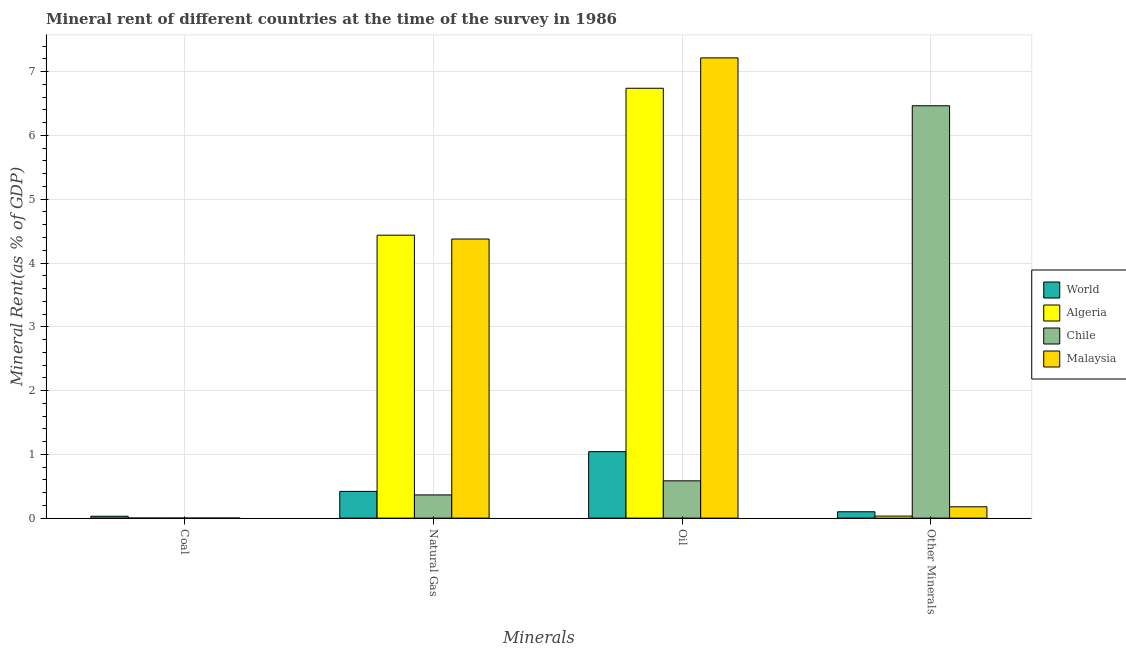How many different coloured bars are there?
Your response must be concise. 4. How many groups of bars are there?
Give a very brief answer. 4. Are the number of bars on each tick of the X-axis equal?
Ensure brevity in your answer.  Yes. What is the label of the 3rd group of bars from the left?
Keep it short and to the point. Oil. What is the natural gas rent in Chile?
Your response must be concise. 0.36. Across all countries, what is the maximum oil rent?
Offer a very short reply. 7.22. Across all countries, what is the minimum oil rent?
Offer a terse response. 0.58. In which country was the  rent of other minerals maximum?
Offer a very short reply. Chile. In which country was the  rent of other minerals minimum?
Ensure brevity in your answer.  Algeria. What is the total natural gas rent in the graph?
Keep it short and to the point. 9.6. What is the difference between the coal rent in Chile and that in Malaysia?
Your answer should be very brief. -0. What is the difference between the coal rent in World and the  rent of other minerals in Malaysia?
Your answer should be compact. -0.15. What is the average natural gas rent per country?
Ensure brevity in your answer.  2.4. What is the difference between the  rent of other minerals and coal rent in Malaysia?
Offer a terse response. 0.18. What is the ratio of the natural gas rent in Algeria to that in Malaysia?
Make the answer very short. 1.01. What is the difference between the highest and the second highest oil rent?
Keep it short and to the point. 0.48. What is the difference between the highest and the lowest coal rent?
Provide a succinct answer. 0.03. In how many countries, is the coal rent greater than the average coal rent taken over all countries?
Offer a very short reply. 1. Is the sum of the coal rent in Algeria and World greater than the maximum oil rent across all countries?
Keep it short and to the point. No. Is it the case that in every country, the sum of the coal rent and natural gas rent is greater than the oil rent?
Keep it short and to the point. No. Are all the bars in the graph horizontal?
Your answer should be compact. No. What is the difference between two consecutive major ticks on the Y-axis?
Offer a very short reply. 1. Are the values on the major ticks of Y-axis written in scientific E-notation?
Keep it short and to the point. No. Does the graph contain any zero values?
Your answer should be compact. No. What is the title of the graph?
Your answer should be compact. Mineral rent of different countries at the time of the survey in 1986. Does "Lebanon" appear as one of the legend labels in the graph?
Make the answer very short. No. What is the label or title of the X-axis?
Your answer should be very brief. Minerals. What is the label or title of the Y-axis?
Offer a very short reply. Mineral Rent(as % of GDP). What is the Mineral Rent(as % of GDP) in World in Coal?
Give a very brief answer. 0.03. What is the Mineral Rent(as % of GDP) of Algeria in Coal?
Make the answer very short. 1.11843058632871e-6. What is the Mineral Rent(as % of GDP) of Chile in Coal?
Your answer should be compact. 0. What is the Mineral Rent(as % of GDP) in Malaysia in Coal?
Your response must be concise. 0. What is the Mineral Rent(as % of GDP) in World in Natural Gas?
Offer a terse response. 0.42. What is the Mineral Rent(as % of GDP) of Algeria in Natural Gas?
Your answer should be compact. 4.44. What is the Mineral Rent(as % of GDP) in Chile in Natural Gas?
Offer a terse response. 0.36. What is the Mineral Rent(as % of GDP) of Malaysia in Natural Gas?
Provide a succinct answer. 4.38. What is the Mineral Rent(as % of GDP) of World in Oil?
Offer a terse response. 1.04. What is the Mineral Rent(as % of GDP) in Algeria in Oil?
Make the answer very short. 6.74. What is the Mineral Rent(as % of GDP) of Chile in Oil?
Your answer should be compact. 0.58. What is the Mineral Rent(as % of GDP) of Malaysia in Oil?
Ensure brevity in your answer.  7.22. What is the Mineral Rent(as % of GDP) in World in Other Minerals?
Keep it short and to the point. 0.1. What is the Mineral Rent(as % of GDP) of Algeria in Other Minerals?
Make the answer very short. 0.03. What is the Mineral Rent(as % of GDP) of Chile in Other Minerals?
Provide a succinct answer. 6.47. What is the Mineral Rent(as % of GDP) of Malaysia in Other Minerals?
Provide a short and direct response. 0.18. Across all Minerals, what is the maximum Mineral Rent(as % of GDP) of World?
Provide a succinct answer. 1.04. Across all Minerals, what is the maximum Mineral Rent(as % of GDP) in Algeria?
Provide a succinct answer. 6.74. Across all Minerals, what is the maximum Mineral Rent(as % of GDP) of Chile?
Give a very brief answer. 6.47. Across all Minerals, what is the maximum Mineral Rent(as % of GDP) of Malaysia?
Your response must be concise. 7.22. Across all Minerals, what is the minimum Mineral Rent(as % of GDP) of World?
Ensure brevity in your answer.  0.03. Across all Minerals, what is the minimum Mineral Rent(as % of GDP) in Algeria?
Provide a short and direct response. 1.11843058632871e-6. Across all Minerals, what is the minimum Mineral Rent(as % of GDP) of Chile?
Offer a terse response. 0. Across all Minerals, what is the minimum Mineral Rent(as % of GDP) of Malaysia?
Give a very brief answer. 0. What is the total Mineral Rent(as % of GDP) in World in the graph?
Keep it short and to the point. 1.59. What is the total Mineral Rent(as % of GDP) of Algeria in the graph?
Offer a terse response. 11.21. What is the total Mineral Rent(as % of GDP) in Chile in the graph?
Offer a terse response. 7.41. What is the total Mineral Rent(as % of GDP) of Malaysia in the graph?
Provide a short and direct response. 11.77. What is the difference between the Mineral Rent(as % of GDP) in World in Coal and that in Natural Gas?
Provide a short and direct response. -0.39. What is the difference between the Mineral Rent(as % of GDP) of Algeria in Coal and that in Natural Gas?
Offer a terse response. -4.44. What is the difference between the Mineral Rent(as % of GDP) in Chile in Coal and that in Natural Gas?
Provide a succinct answer. -0.36. What is the difference between the Mineral Rent(as % of GDP) in Malaysia in Coal and that in Natural Gas?
Offer a terse response. -4.38. What is the difference between the Mineral Rent(as % of GDP) of World in Coal and that in Oil?
Ensure brevity in your answer.  -1.01. What is the difference between the Mineral Rent(as % of GDP) of Algeria in Coal and that in Oil?
Give a very brief answer. -6.74. What is the difference between the Mineral Rent(as % of GDP) in Chile in Coal and that in Oil?
Give a very brief answer. -0.58. What is the difference between the Mineral Rent(as % of GDP) in Malaysia in Coal and that in Oil?
Give a very brief answer. -7.22. What is the difference between the Mineral Rent(as % of GDP) in World in Coal and that in Other Minerals?
Offer a terse response. -0.07. What is the difference between the Mineral Rent(as % of GDP) of Algeria in Coal and that in Other Minerals?
Ensure brevity in your answer.  -0.03. What is the difference between the Mineral Rent(as % of GDP) of Chile in Coal and that in Other Minerals?
Give a very brief answer. -6.47. What is the difference between the Mineral Rent(as % of GDP) of Malaysia in Coal and that in Other Minerals?
Your response must be concise. -0.18. What is the difference between the Mineral Rent(as % of GDP) in World in Natural Gas and that in Oil?
Your answer should be compact. -0.62. What is the difference between the Mineral Rent(as % of GDP) of Algeria in Natural Gas and that in Oil?
Your answer should be compact. -2.3. What is the difference between the Mineral Rent(as % of GDP) of Chile in Natural Gas and that in Oil?
Keep it short and to the point. -0.22. What is the difference between the Mineral Rent(as % of GDP) in Malaysia in Natural Gas and that in Oil?
Ensure brevity in your answer.  -2.84. What is the difference between the Mineral Rent(as % of GDP) in World in Natural Gas and that in Other Minerals?
Offer a very short reply. 0.32. What is the difference between the Mineral Rent(as % of GDP) of Algeria in Natural Gas and that in Other Minerals?
Give a very brief answer. 4.4. What is the difference between the Mineral Rent(as % of GDP) in Chile in Natural Gas and that in Other Minerals?
Your answer should be compact. -6.1. What is the difference between the Mineral Rent(as % of GDP) in Malaysia in Natural Gas and that in Other Minerals?
Your answer should be very brief. 4.2. What is the difference between the Mineral Rent(as % of GDP) of World in Oil and that in Other Minerals?
Your response must be concise. 0.94. What is the difference between the Mineral Rent(as % of GDP) in Algeria in Oil and that in Other Minerals?
Offer a very short reply. 6.71. What is the difference between the Mineral Rent(as % of GDP) of Chile in Oil and that in Other Minerals?
Offer a very short reply. -5.88. What is the difference between the Mineral Rent(as % of GDP) in Malaysia in Oil and that in Other Minerals?
Ensure brevity in your answer.  7.04. What is the difference between the Mineral Rent(as % of GDP) of World in Coal and the Mineral Rent(as % of GDP) of Algeria in Natural Gas?
Ensure brevity in your answer.  -4.41. What is the difference between the Mineral Rent(as % of GDP) in World in Coal and the Mineral Rent(as % of GDP) in Chile in Natural Gas?
Ensure brevity in your answer.  -0.33. What is the difference between the Mineral Rent(as % of GDP) of World in Coal and the Mineral Rent(as % of GDP) of Malaysia in Natural Gas?
Give a very brief answer. -4.35. What is the difference between the Mineral Rent(as % of GDP) in Algeria in Coal and the Mineral Rent(as % of GDP) in Chile in Natural Gas?
Offer a very short reply. -0.36. What is the difference between the Mineral Rent(as % of GDP) of Algeria in Coal and the Mineral Rent(as % of GDP) of Malaysia in Natural Gas?
Offer a terse response. -4.38. What is the difference between the Mineral Rent(as % of GDP) of Chile in Coal and the Mineral Rent(as % of GDP) of Malaysia in Natural Gas?
Offer a terse response. -4.38. What is the difference between the Mineral Rent(as % of GDP) of World in Coal and the Mineral Rent(as % of GDP) of Algeria in Oil?
Offer a very short reply. -6.71. What is the difference between the Mineral Rent(as % of GDP) in World in Coal and the Mineral Rent(as % of GDP) in Chile in Oil?
Provide a succinct answer. -0.56. What is the difference between the Mineral Rent(as % of GDP) in World in Coal and the Mineral Rent(as % of GDP) in Malaysia in Oil?
Your response must be concise. -7.19. What is the difference between the Mineral Rent(as % of GDP) in Algeria in Coal and the Mineral Rent(as % of GDP) in Chile in Oil?
Ensure brevity in your answer.  -0.58. What is the difference between the Mineral Rent(as % of GDP) of Algeria in Coal and the Mineral Rent(as % of GDP) of Malaysia in Oil?
Give a very brief answer. -7.22. What is the difference between the Mineral Rent(as % of GDP) of Chile in Coal and the Mineral Rent(as % of GDP) of Malaysia in Oil?
Ensure brevity in your answer.  -7.22. What is the difference between the Mineral Rent(as % of GDP) in World in Coal and the Mineral Rent(as % of GDP) in Algeria in Other Minerals?
Your response must be concise. -0. What is the difference between the Mineral Rent(as % of GDP) of World in Coal and the Mineral Rent(as % of GDP) of Chile in Other Minerals?
Give a very brief answer. -6.44. What is the difference between the Mineral Rent(as % of GDP) in World in Coal and the Mineral Rent(as % of GDP) in Malaysia in Other Minerals?
Provide a succinct answer. -0.15. What is the difference between the Mineral Rent(as % of GDP) in Algeria in Coal and the Mineral Rent(as % of GDP) in Chile in Other Minerals?
Keep it short and to the point. -6.47. What is the difference between the Mineral Rent(as % of GDP) in Algeria in Coal and the Mineral Rent(as % of GDP) in Malaysia in Other Minerals?
Your answer should be compact. -0.18. What is the difference between the Mineral Rent(as % of GDP) of Chile in Coal and the Mineral Rent(as % of GDP) of Malaysia in Other Minerals?
Your answer should be compact. -0.18. What is the difference between the Mineral Rent(as % of GDP) in World in Natural Gas and the Mineral Rent(as % of GDP) in Algeria in Oil?
Your answer should be compact. -6.32. What is the difference between the Mineral Rent(as % of GDP) in World in Natural Gas and the Mineral Rent(as % of GDP) in Chile in Oil?
Keep it short and to the point. -0.17. What is the difference between the Mineral Rent(as % of GDP) of World in Natural Gas and the Mineral Rent(as % of GDP) of Malaysia in Oil?
Your response must be concise. -6.8. What is the difference between the Mineral Rent(as % of GDP) in Algeria in Natural Gas and the Mineral Rent(as % of GDP) in Chile in Oil?
Your response must be concise. 3.85. What is the difference between the Mineral Rent(as % of GDP) in Algeria in Natural Gas and the Mineral Rent(as % of GDP) in Malaysia in Oil?
Ensure brevity in your answer.  -2.78. What is the difference between the Mineral Rent(as % of GDP) of Chile in Natural Gas and the Mineral Rent(as % of GDP) of Malaysia in Oil?
Offer a very short reply. -6.85. What is the difference between the Mineral Rent(as % of GDP) in World in Natural Gas and the Mineral Rent(as % of GDP) in Algeria in Other Minerals?
Offer a terse response. 0.39. What is the difference between the Mineral Rent(as % of GDP) of World in Natural Gas and the Mineral Rent(as % of GDP) of Chile in Other Minerals?
Give a very brief answer. -6.05. What is the difference between the Mineral Rent(as % of GDP) in World in Natural Gas and the Mineral Rent(as % of GDP) in Malaysia in Other Minerals?
Make the answer very short. 0.24. What is the difference between the Mineral Rent(as % of GDP) of Algeria in Natural Gas and the Mineral Rent(as % of GDP) of Chile in Other Minerals?
Offer a very short reply. -2.03. What is the difference between the Mineral Rent(as % of GDP) in Algeria in Natural Gas and the Mineral Rent(as % of GDP) in Malaysia in Other Minerals?
Make the answer very short. 4.26. What is the difference between the Mineral Rent(as % of GDP) of Chile in Natural Gas and the Mineral Rent(as % of GDP) of Malaysia in Other Minerals?
Offer a terse response. 0.19. What is the difference between the Mineral Rent(as % of GDP) of World in Oil and the Mineral Rent(as % of GDP) of Algeria in Other Minerals?
Provide a succinct answer. 1.01. What is the difference between the Mineral Rent(as % of GDP) in World in Oil and the Mineral Rent(as % of GDP) in Chile in Other Minerals?
Your answer should be compact. -5.42. What is the difference between the Mineral Rent(as % of GDP) of World in Oil and the Mineral Rent(as % of GDP) of Malaysia in Other Minerals?
Provide a succinct answer. 0.86. What is the difference between the Mineral Rent(as % of GDP) in Algeria in Oil and the Mineral Rent(as % of GDP) in Chile in Other Minerals?
Provide a succinct answer. 0.27. What is the difference between the Mineral Rent(as % of GDP) in Algeria in Oil and the Mineral Rent(as % of GDP) in Malaysia in Other Minerals?
Your response must be concise. 6.56. What is the difference between the Mineral Rent(as % of GDP) of Chile in Oil and the Mineral Rent(as % of GDP) of Malaysia in Other Minerals?
Your answer should be compact. 0.41. What is the average Mineral Rent(as % of GDP) of World per Minerals?
Provide a succinct answer. 0.4. What is the average Mineral Rent(as % of GDP) of Algeria per Minerals?
Provide a succinct answer. 2.8. What is the average Mineral Rent(as % of GDP) of Chile per Minerals?
Provide a succinct answer. 1.85. What is the average Mineral Rent(as % of GDP) in Malaysia per Minerals?
Make the answer very short. 2.94. What is the difference between the Mineral Rent(as % of GDP) in World and Mineral Rent(as % of GDP) in Algeria in Coal?
Make the answer very short. 0.03. What is the difference between the Mineral Rent(as % of GDP) of World and Mineral Rent(as % of GDP) of Chile in Coal?
Offer a very short reply. 0.03. What is the difference between the Mineral Rent(as % of GDP) in World and Mineral Rent(as % of GDP) in Malaysia in Coal?
Make the answer very short. 0.03. What is the difference between the Mineral Rent(as % of GDP) in Algeria and Mineral Rent(as % of GDP) in Chile in Coal?
Provide a short and direct response. -0. What is the difference between the Mineral Rent(as % of GDP) in Algeria and Mineral Rent(as % of GDP) in Malaysia in Coal?
Provide a succinct answer. -0. What is the difference between the Mineral Rent(as % of GDP) of Chile and Mineral Rent(as % of GDP) of Malaysia in Coal?
Provide a short and direct response. -0. What is the difference between the Mineral Rent(as % of GDP) in World and Mineral Rent(as % of GDP) in Algeria in Natural Gas?
Your answer should be very brief. -4.02. What is the difference between the Mineral Rent(as % of GDP) of World and Mineral Rent(as % of GDP) of Chile in Natural Gas?
Offer a very short reply. 0.06. What is the difference between the Mineral Rent(as % of GDP) of World and Mineral Rent(as % of GDP) of Malaysia in Natural Gas?
Offer a very short reply. -3.96. What is the difference between the Mineral Rent(as % of GDP) in Algeria and Mineral Rent(as % of GDP) in Chile in Natural Gas?
Your answer should be compact. 4.07. What is the difference between the Mineral Rent(as % of GDP) of Algeria and Mineral Rent(as % of GDP) of Malaysia in Natural Gas?
Make the answer very short. 0.06. What is the difference between the Mineral Rent(as % of GDP) in Chile and Mineral Rent(as % of GDP) in Malaysia in Natural Gas?
Your response must be concise. -4.01. What is the difference between the Mineral Rent(as % of GDP) of World and Mineral Rent(as % of GDP) of Algeria in Oil?
Your answer should be very brief. -5.7. What is the difference between the Mineral Rent(as % of GDP) of World and Mineral Rent(as % of GDP) of Chile in Oil?
Provide a succinct answer. 0.46. What is the difference between the Mineral Rent(as % of GDP) in World and Mineral Rent(as % of GDP) in Malaysia in Oil?
Offer a terse response. -6.17. What is the difference between the Mineral Rent(as % of GDP) in Algeria and Mineral Rent(as % of GDP) in Chile in Oil?
Give a very brief answer. 6.16. What is the difference between the Mineral Rent(as % of GDP) in Algeria and Mineral Rent(as % of GDP) in Malaysia in Oil?
Your answer should be compact. -0.48. What is the difference between the Mineral Rent(as % of GDP) of Chile and Mineral Rent(as % of GDP) of Malaysia in Oil?
Provide a short and direct response. -6.63. What is the difference between the Mineral Rent(as % of GDP) of World and Mineral Rent(as % of GDP) of Algeria in Other Minerals?
Offer a very short reply. 0.07. What is the difference between the Mineral Rent(as % of GDP) of World and Mineral Rent(as % of GDP) of Chile in Other Minerals?
Offer a terse response. -6.37. What is the difference between the Mineral Rent(as % of GDP) in World and Mineral Rent(as % of GDP) in Malaysia in Other Minerals?
Your answer should be compact. -0.08. What is the difference between the Mineral Rent(as % of GDP) of Algeria and Mineral Rent(as % of GDP) of Chile in Other Minerals?
Offer a very short reply. -6.43. What is the difference between the Mineral Rent(as % of GDP) of Algeria and Mineral Rent(as % of GDP) of Malaysia in Other Minerals?
Provide a succinct answer. -0.15. What is the difference between the Mineral Rent(as % of GDP) in Chile and Mineral Rent(as % of GDP) in Malaysia in Other Minerals?
Your answer should be compact. 6.29. What is the ratio of the Mineral Rent(as % of GDP) of World in Coal to that in Natural Gas?
Make the answer very short. 0.07. What is the ratio of the Mineral Rent(as % of GDP) of World in Coal to that in Oil?
Provide a short and direct response. 0.03. What is the ratio of the Mineral Rent(as % of GDP) in Chile in Coal to that in Oil?
Your answer should be compact. 0. What is the ratio of the Mineral Rent(as % of GDP) in World in Coal to that in Other Minerals?
Make the answer very short. 0.29. What is the ratio of the Mineral Rent(as % of GDP) in Chile in Coal to that in Other Minerals?
Provide a short and direct response. 0. What is the ratio of the Mineral Rent(as % of GDP) of Malaysia in Coal to that in Other Minerals?
Give a very brief answer. 0. What is the ratio of the Mineral Rent(as % of GDP) in World in Natural Gas to that in Oil?
Provide a succinct answer. 0.4. What is the ratio of the Mineral Rent(as % of GDP) in Algeria in Natural Gas to that in Oil?
Give a very brief answer. 0.66. What is the ratio of the Mineral Rent(as % of GDP) in Chile in Natural Gas to that in Oil?
Make the answer very short. 0.62. What is the ratio of the Mineral Rent(as % of GDP) in Malaysia in Natural Gas to that in Oil?
Your response must be concise. 0.61. What is the ratio of the Mineral Rent(as % of GDP) in World in Natural Gas to that in Other Minerals?
Offer a terse response. 4.21. What is the ratio of the Mineral Rent(as % of GDP) in Algeria in Natural Gas to that in Other Minerals?
Your answer should be very brief. 139.7. What is the ratio of the Mineral Rent(as % of GDP) of Chile in Natural Gas to that in Other Minerals?
Your answer should be very brief. 0.06. What is the ratio of the Mineral Rent(as % of GDP) in Malaysia in Natural Gas to that in Other Minerals?
Your response must be concise. 24.64. What is the ratio of the Mineral Rent(as % of GDP) of World in Oil to that in Other Minerals?
Your response must be concise. 10.47. What is the ratio of the Mineral Rent(as % of GDP) of Algeria in Oil to that in Other Minerals?
Provide a succinct answer. 212.25. What is the ratio of the Mineral Rent(as % of GDP) of Chile in Oil to that in Other Minerals?
Your answer should be compact. 0.09. What is the ratio of the Mineral Rent(as % of GDP) in Malaysia in Oil to that in Other Minerals?
Make the answer very short. 40.63. What is the difference between the highest and the second highest Mineral Rent(as % of GDP) in World?
Make the answer very short. 0.62. What is the difference between the highest and the second highest Mineral Rent(as % of GDP) of Algeria?
Offer a terse response. 2.3. What is the difference between the highest and the second highest Mineral Rent(as % of GDP) of Chile?
Provide a succinct answer. 5.88. What is the difference between the highest and the second highest Mineral Rent(as % of GDP) of Malaysia?
Give a very brief answer. 2.84. What is the difference between the highest and the lowest Mineral Rent(as % of GDP) of World?
Offer a terse response. 1.01. What is the difference between the highest and the lowest Mineral Rent(as % of GDP) of Algeria?
Offer a terse response. 6.74. What is the difference between the highest and the lowest Mineral Rent(as % of GDP) in Chile?
Keep it short and to the point. 6.47. What is the difference between the highest and the lowest Mineral Rent(as % of GDP) of Malaysia?
Provide a succinct answer. 7.22. 